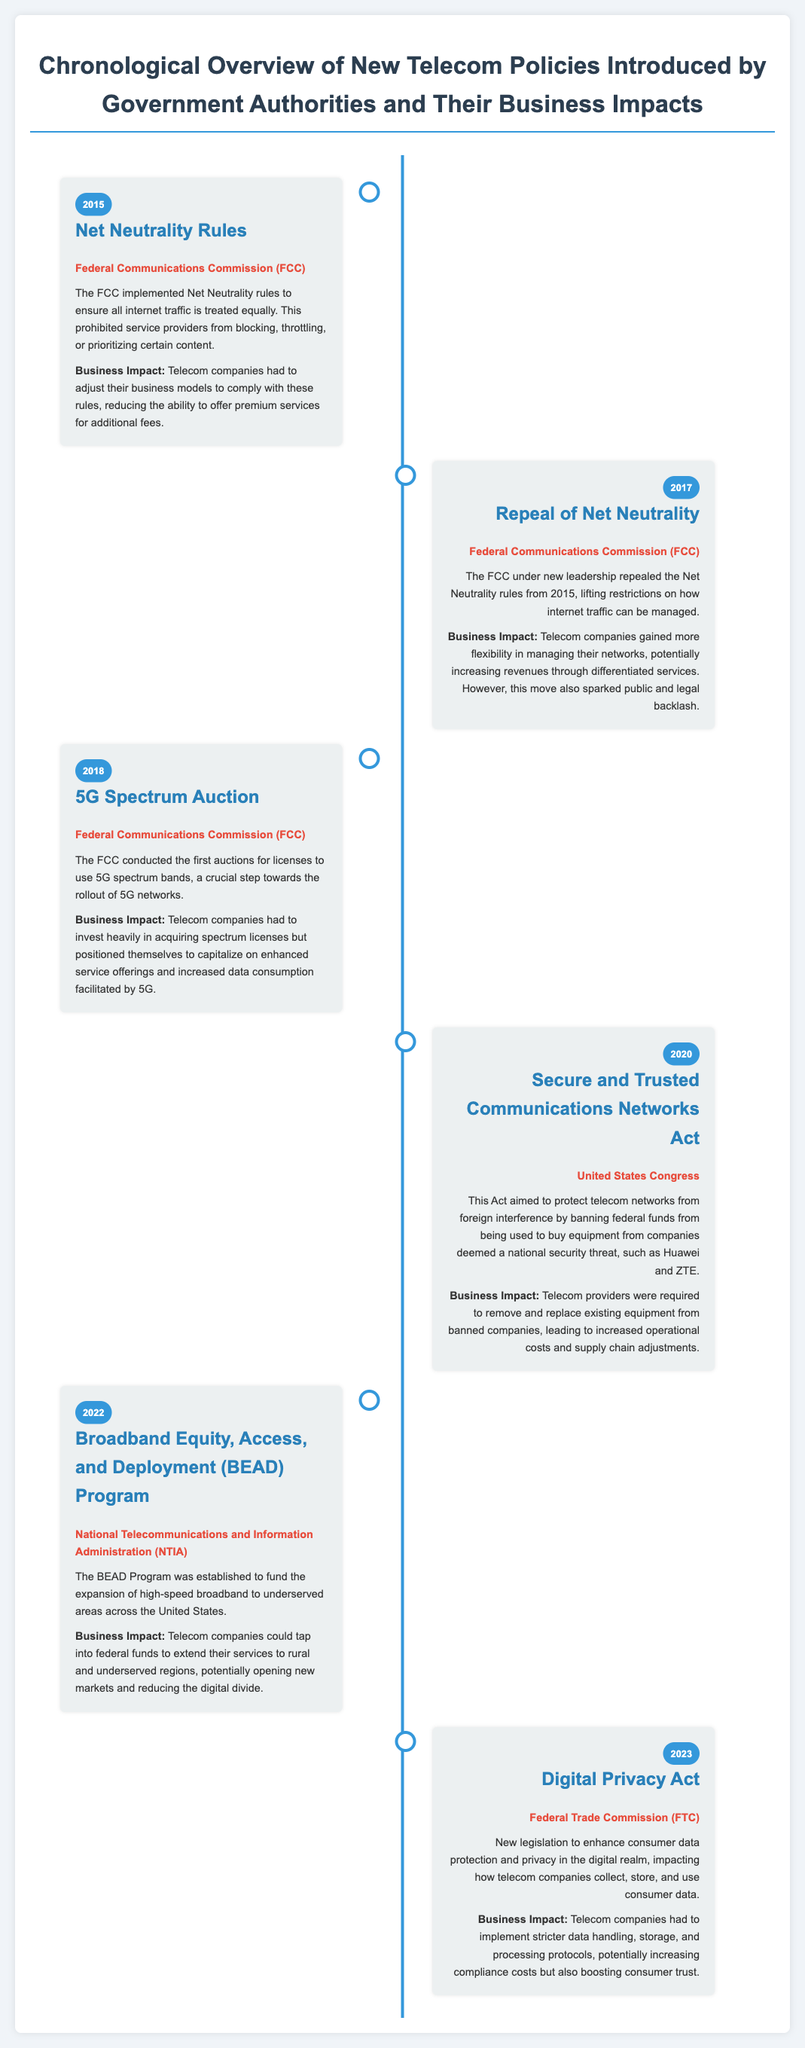What year were the Net Neutrality Rules implemented? The document states that Net Neutrality Rules were implemented in 2015.
Answer: 2015 Which agency repealed Net Neutrality in 2017? The document mentions that the Federal Communications Commission (FCC) repealed Net Neutrality.
Answer: Federal Communications Commission (FCC) What was conducted in 2018 related to 5G? The document states that a 5G Spectrum Auction was conducted in 2018.
Answer: 5G Spectrum Auction What Act was introduced in 2020? The document states that the Secure and Trusted Communications Networks Act was introduced in 2020.
Answer: Secure and Trusted Communications Networks Act What was the business impact of the Broadband Equity, Access, and Deployment (BEAD) Program? The document indicates that telecom companies could tap into federal funds to extend their services to new markets.
Answer: Open new markets What is the main purpose of the Digital Privacy Act introduced in 2023? The document explains that the Digital Privacy Act enhances consumer data protection and privacy.
Answer: Enhance consumer data protection How did the repeal of Net Neutrality impact telecom companies financially? The document states that telecom companies gained flexibility to increase revenues through differentiated services.
Answer: Increased revenues Which government body introduced the BEAD Program? The document specifies that the National Telecommunications and Information Administration (NTIA) established the BEAD Program.
Answer: National Telecommunications and Information Administration (NTIA) What is the main theme of this timeline infographic? The document emphasizes a chronological overview of new telecom policies introduced and their business impacts.
Answer: Telecom policies and business impacts 